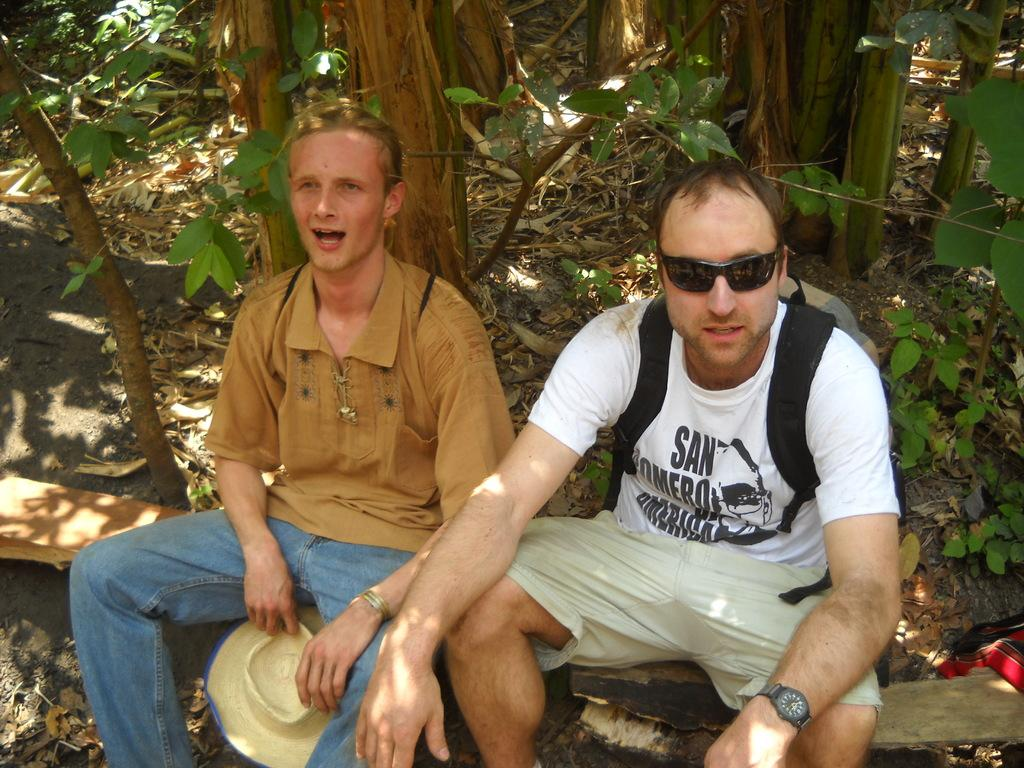How many people are sitting in the image? There are two people sitting in the image. What are the people sitting on? The people are sitting on a surface. What can be seen in the background of the image? There are trees visible in the image. Is the dad in the image a spy? There is no mention of a dad or a spy in the image, so we cannot determine if the dad is a spy. 